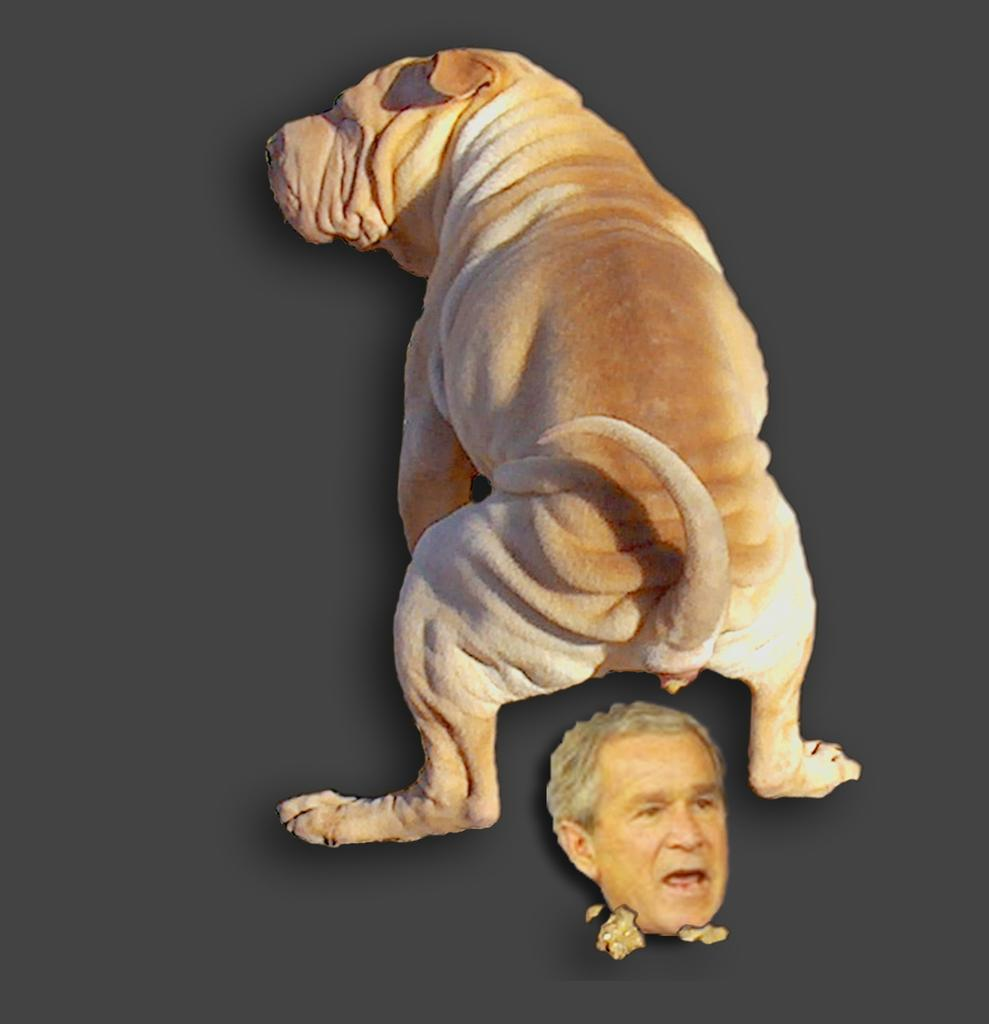What is the main subject in the center of the image? There is a dog in the center of the image. Can you describe the other element present in the image? There is a person's face at the bottom of the image. What type of blood is visible on the dog's fur in the image? There is no blood visible on the dog's fur in the image. How is the person's face sorted in the image? The person's face is not sorted in the image; it is simply present at the bottom. 